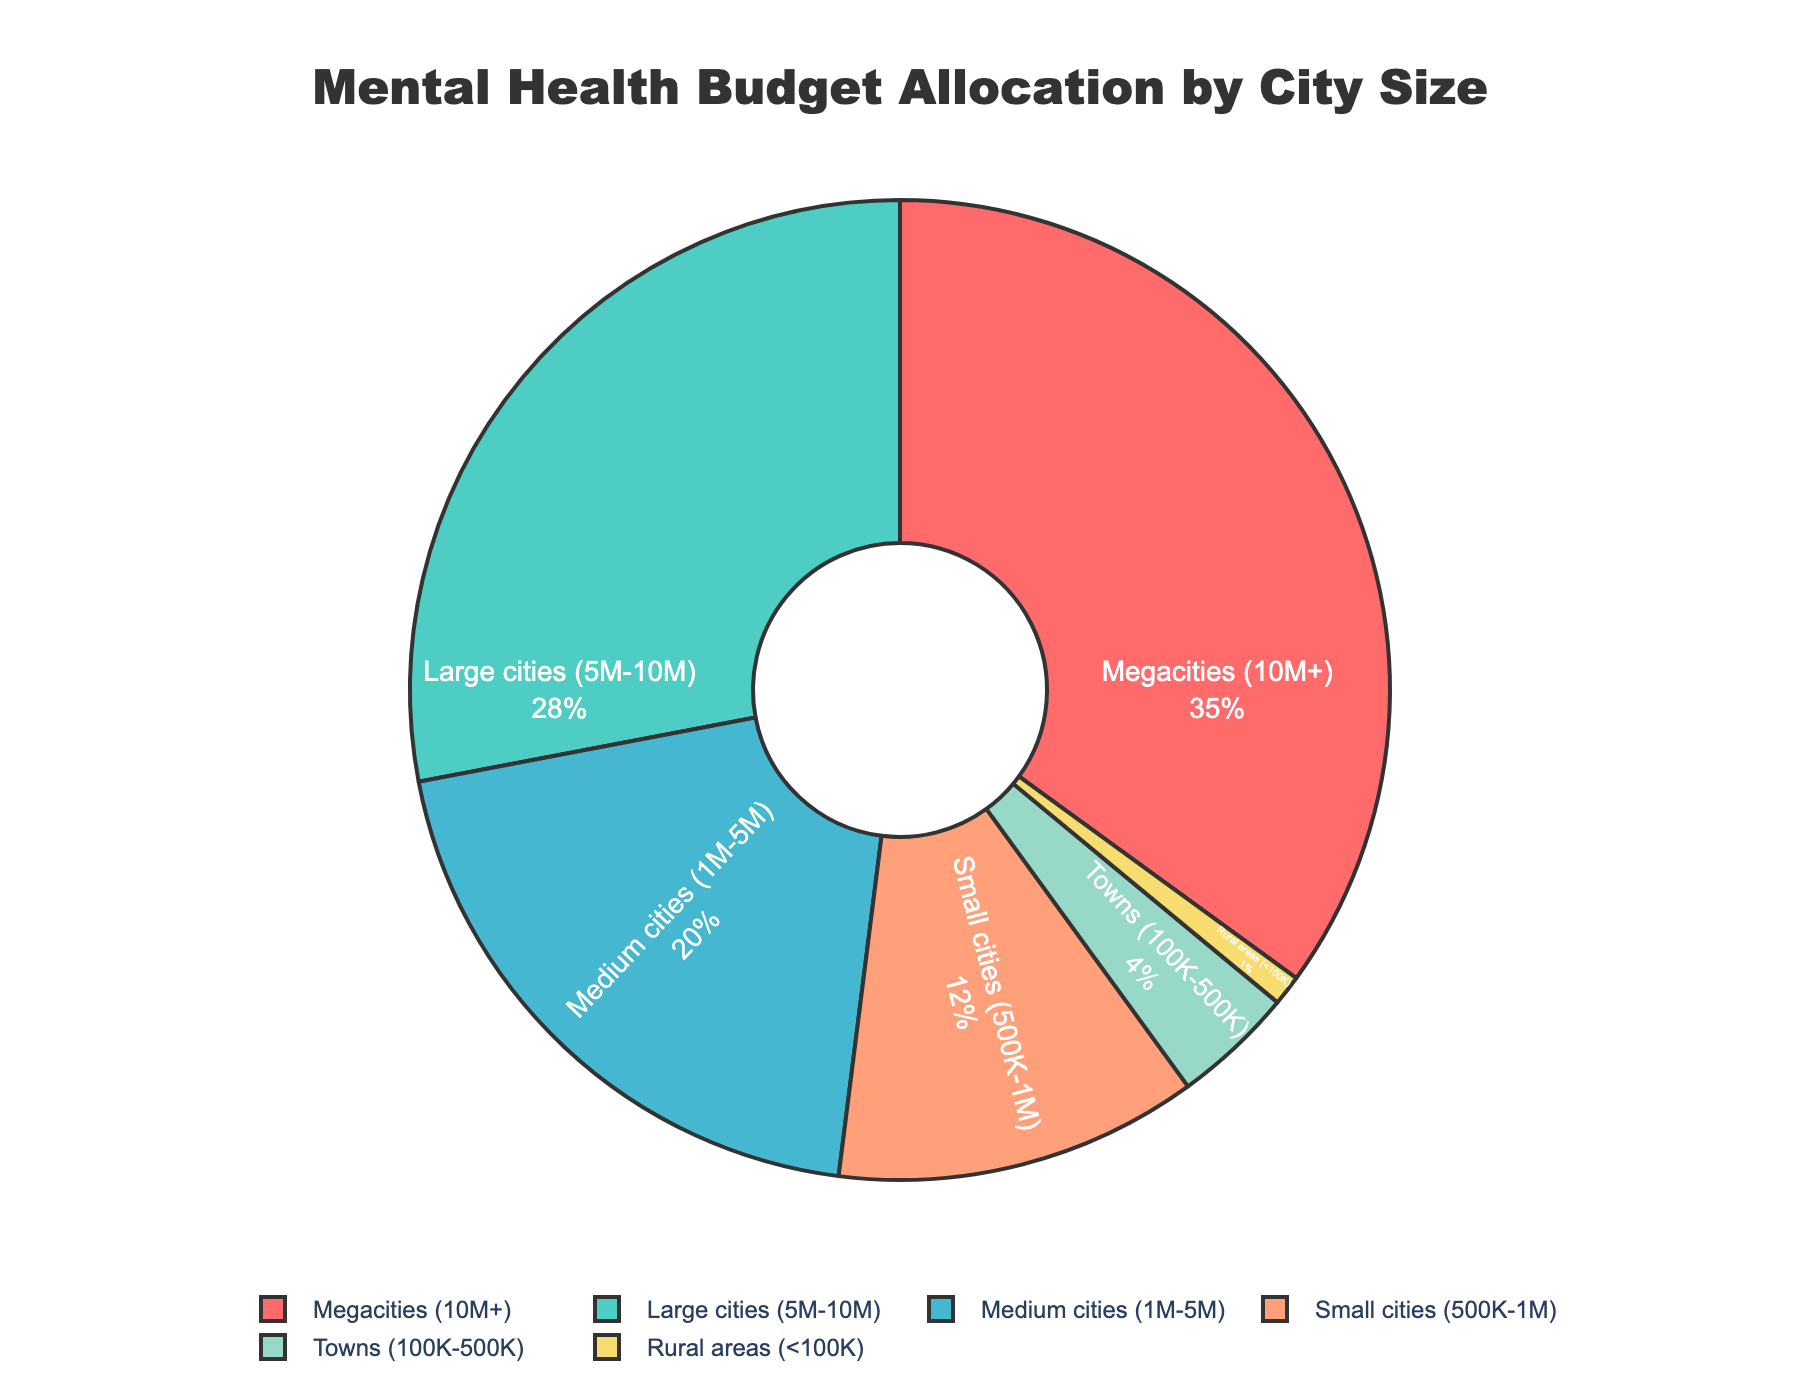Which city size receives the highest percentage of the mental health budget? To find the city size with the highest percentage, look at the segments of the pie chart and identify which segment occupies the largest area. The Megacity segment is the largest.
Answer: Megacities How does the budget allocation for Large cities compare to that for Small cities? Compare the percentage allocations of Large cities and Small cities. Large cities receive 28%, while Small cities receive 12%. So, Large cities get more allocation.
Answer: Larger What is the combined percentage allocation for cities with populations less than 5 million? Sum the percentages for Medium cities (20%), Small cities (12%), Towns (4%), and Rural areas (1%). 20 + 12 + 4 + 1 = 37%.
Answer: 37% Which city size receives the lowest percentage of the mental health budget? Look at the pie chart and identify the segment with the smallest area. The Rural areas segment is the smallest.
Answer: Rural areas Is the budget allocation for Megacities more than double that for Medium cities? Compare the percentage allocation for Megacities (35%) and Medium cities (20%). Double of Medium cities' allocation is 40%, which is higher than Megacities' 35%.
Answer: No What is the difference in budget allocation between Megacities and Large cities? Subtract the percentage for Large cities (28%) from that for Megacities (35%). 35 - 28 = 7%.
Answer: 7% What is the percentage allocation for the three largest city sizes combined? Sum the percentages for Megacities (35%), Large cities (28%), and Medium cities (20%). 35 + 28 + 20 = 83%.
Answer: 83% How does the percentage of the budget allocated to Small cities compare to that for Towns? Compare the percentages allocated to Small cities (12%) and Towns (4%). Small cities receive a higher percentage.
Answer: Higher What proportion of the budget is allocated to cities with populations greater than or equal to 1 million? Sum the percentages for Megacities (35%), Large cities (28%), and Medium cities (20%). 35 + 28 + 20 = 83%.
Answer: 83% Is the allocation for both Small cities and Towns greater than the allocation for Medium cities? Compare the combined percentage for Small cities (12%) and Towns (4%), which totals 16%, to the percentage for Medium cities (20%). 16% is less than 20%.
Answer: No 